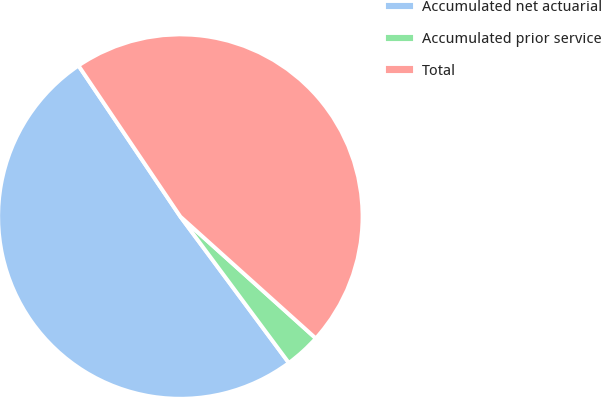<chart> <loc_0><loc_0><loc_500><loc_500><pie_chart><fcel>Accumulated net actuarial<fcel>Accumulated prior service<fcel>Total<nl><fcel>50.71%<fcel>3.19%<fcel>46.1%<nl></chart> 